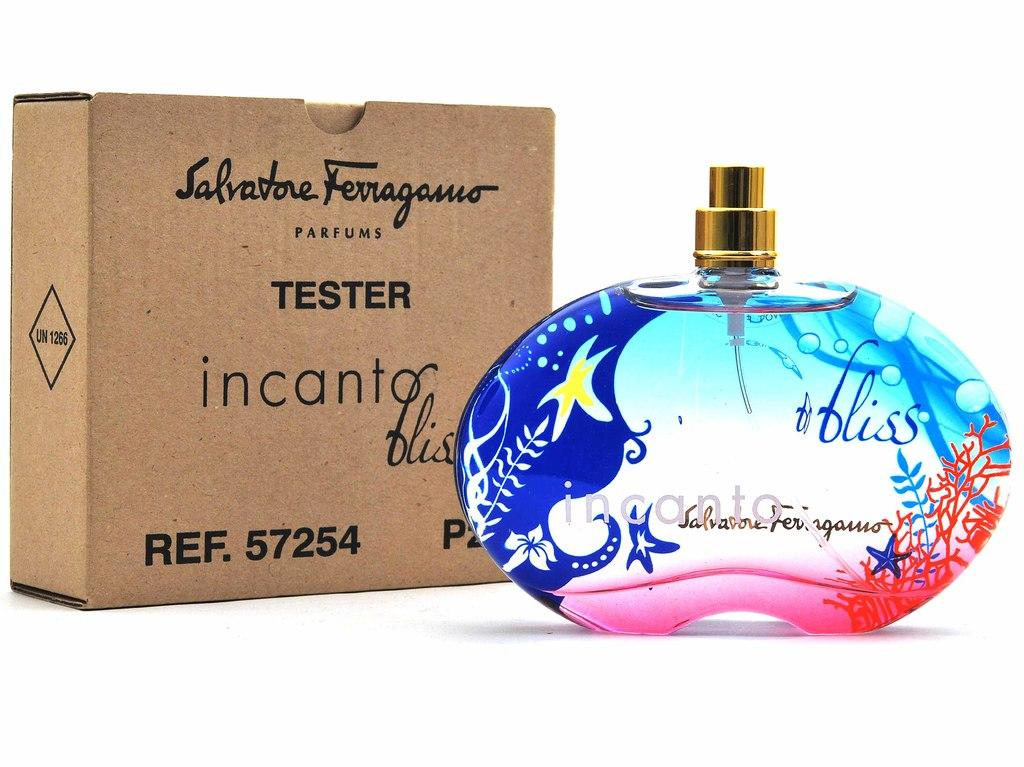<image>
Offer a succinct explanation of the picture presented. A bottle of incanto perfume is next to the box it came in. 